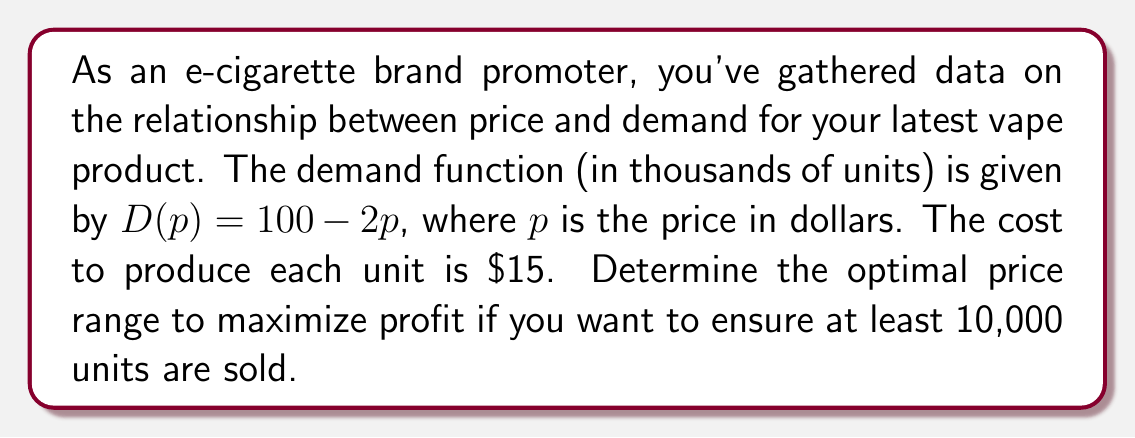Can you solve this math problem? 1) First, let's set up the profit function. Profit is revenue minus cost:
   $P(p) = pD(p) - 15D(p)$

2) Substitute the demand function:
   $P(p) = p(100 - 2p) - 15(100 - 2p)$
   $P(p) = 100p - 2p^2 - 1500 + 30p$
   $P(p) = -2p^2 + 130p - 1500$

3) To find the maximum profit, we need to find the vertex of this parabola:
   $p = -\frac{b}{2a} = -\frac{130}{2(-2)} = 32.5$

4) However, we need to ensure at least 10,000 units are sold. Let's check the demand at $p = 32.5$:
   $D(32.5) = 100 - 2(32.5) = 35$ thousand units

5) This satisfies our constraint. Now, let's find the price range where at least 10,000 units are sold:
   $100 - 2p \geq 10$
   $-2p \geq -90$
   $p \leq 45$

6) Therefore, the optimal price should be between $\$32.50$ (for maximum profit) and $\$45$ (to ensure at least 10,000 units sold).
Answer: $\$32.50 \leq p \leq \$45$ 